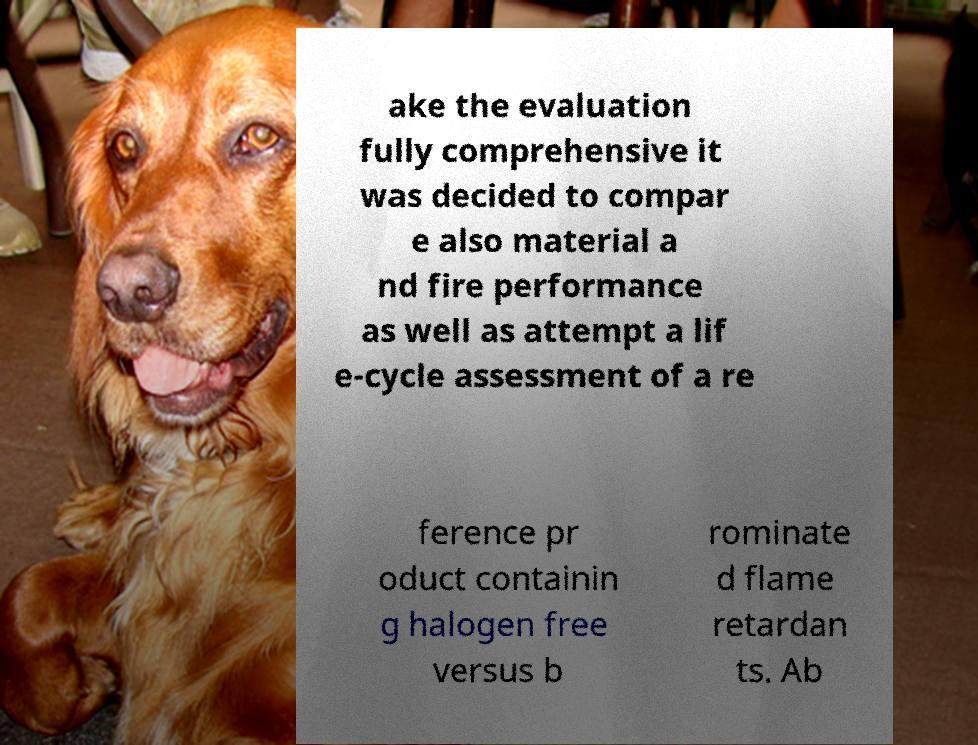Can you read and provide the text displayed in the image?This photo seems to have some interesting text. Can you extract and type it out for me? ake the evaluation fully comprehensive it was decided to compar e also material a nd fire performance as well as attempt a lif e-cycle assessment of a re ference pr oduct containin g halogen free versus b rominate d flame retardan ts. Ab 